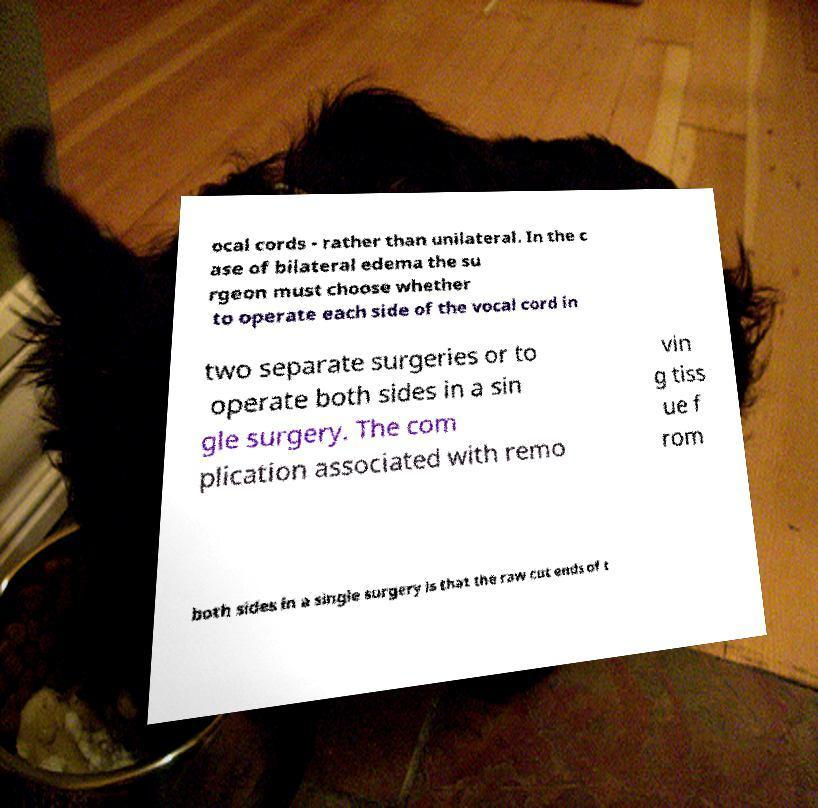Please identify and transcribe the text found in this image. ocal cords - rather than unilateral. In the c ase of bilateral edema the su rgeon must choose whether to operate each side of the vocal cord in two separate surgeries or to operate both sides in a sin gle surgery. The com plication associated with remo vin g tiss ue f rom both sides in a single surgery is that the raw cut ends of t 